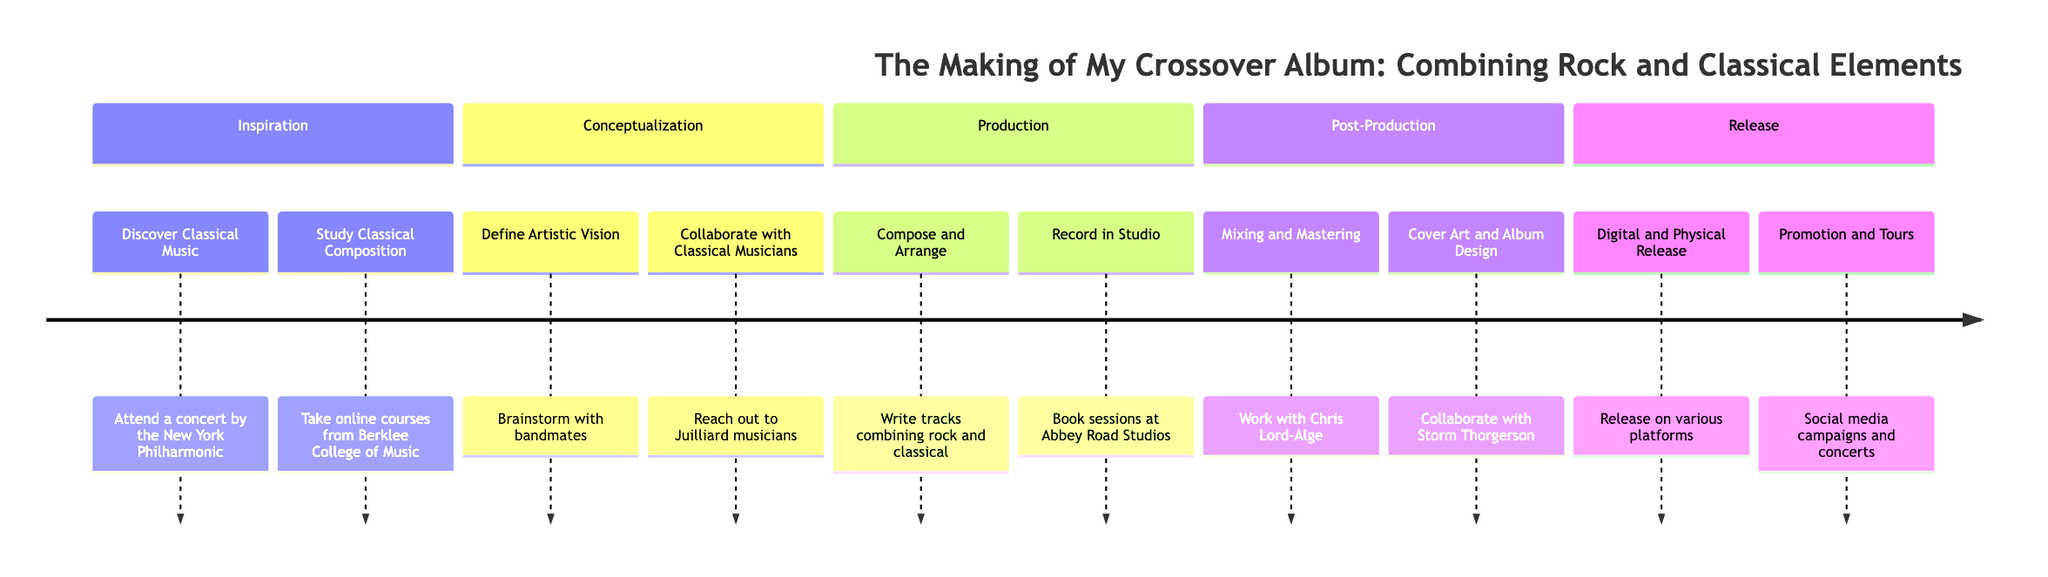What is the first step in the timeline? The first phase of the timeline is "Inspiration," and the first step listed under this phase is "Discover Classical Music."
Answer: Discover Classical Music How many phases are there in the timeline? The timeline consists of five phases: Inspiration, Conceptualization, Production, Post-Production, and Release.
Answer: 5 What is the last step mentioned in the timeline? The last phase is "Release," and the last step listed is "Promotion and Tours."
Answer: Promotion and Tours Which phase includes working with Chris Lord-Alge? The phase titled "Post-Production" includes the step "Mixing and Mastering," where collaboration with Chris Lord-Alge is mentioned.
Answer: Post-Production What are the two elements listed under the Production phase? Under the "Production" phase, the two elements are "Compose and Arrange" and "Record in Studio."
Answer: Compose and Arrange, Record in Studio Which musical institution did you reach out to during Conceptualization? During the "Conceptualization" phase, there was collaboration with musicians from Juilliard.
Answer: Juilliard How many steps are in the Post-Production phase? The "Post-Production" phase contains two steps: "Mixing and Mastering" and "Cover Art and Album Design."
Answer: 2 What is a key location mentioned for recording the album? The key location mentioned for recording the album is "Abbey Road Studios."
Answer: Abbey Road Studios In which phase do you define your artistic vision? The concept of defining the artistic vision is part of the "Conceptualization" phase.
Answer: Conceptualization 